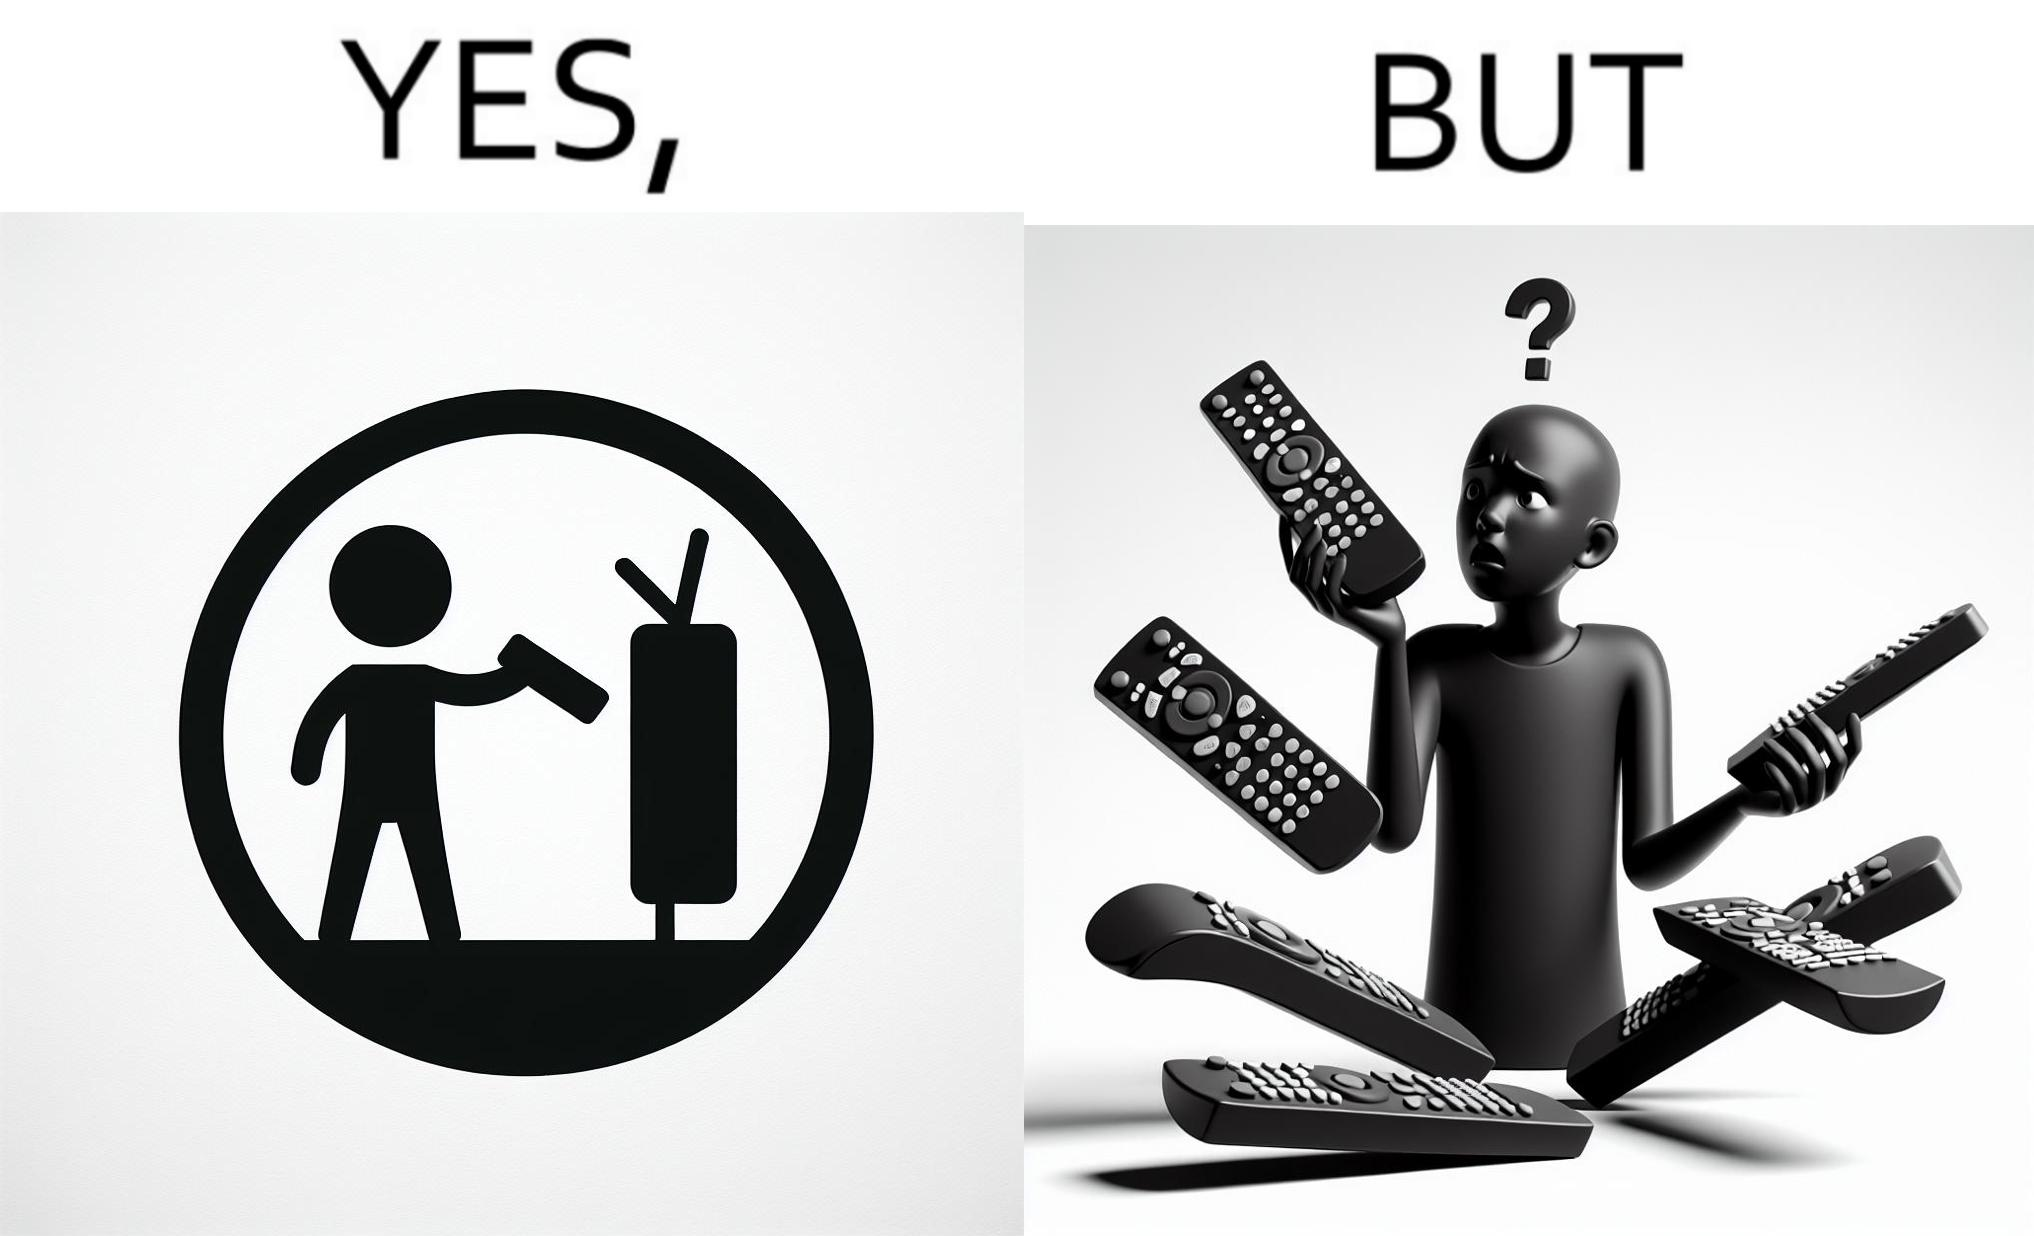Describe the contrast between the left and right parts of this image. In the left part of the image: It is a remote being used to operate a TV In the right part of the image: It is an user confused between multiple remotes 